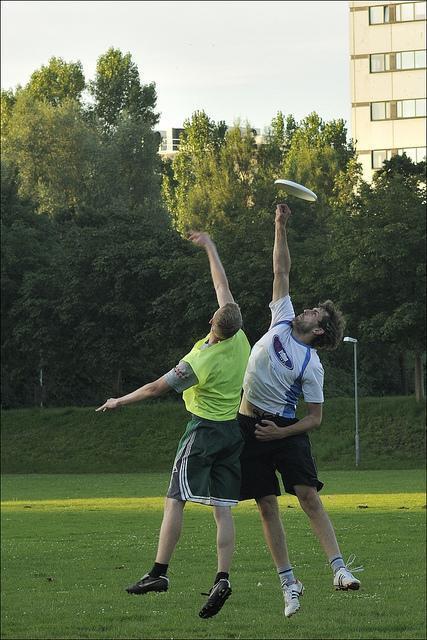How many men can you see?
Give a very brief answer. 2. How many people are there?
Give a very brief answer. 2. 